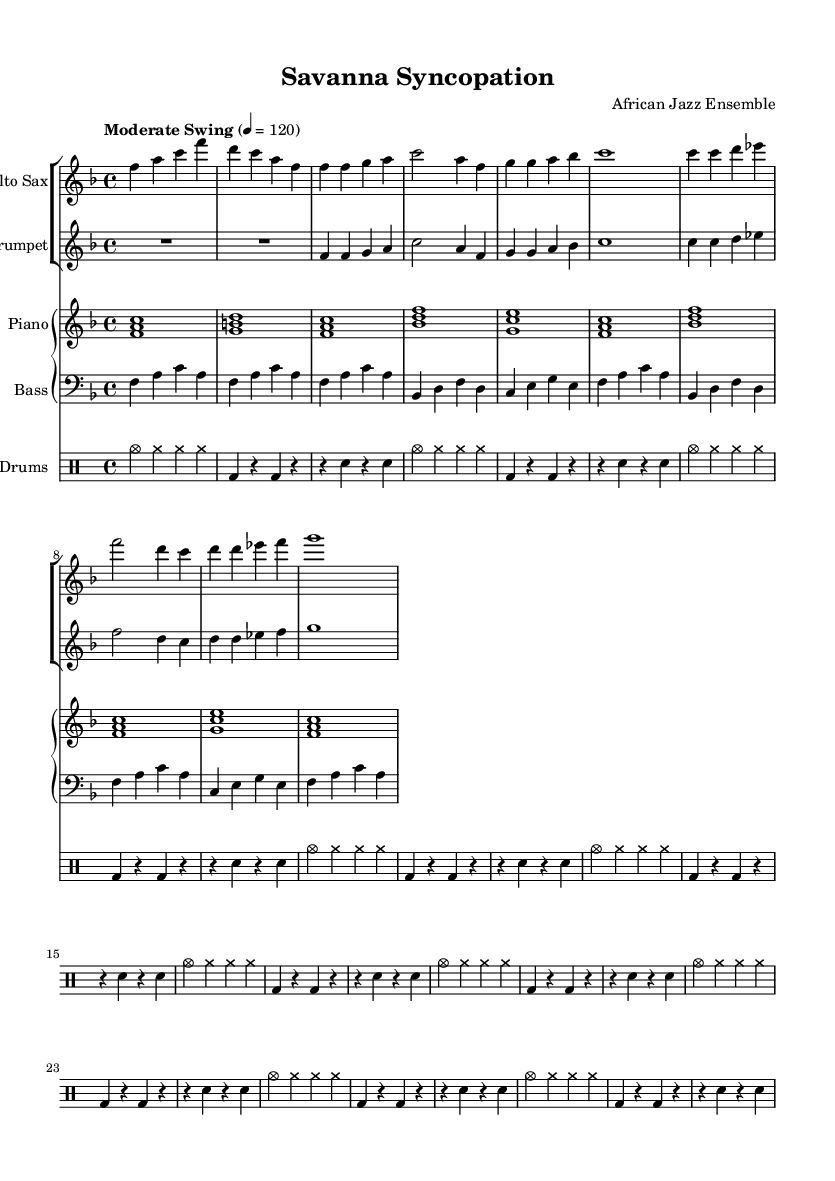What is the key signature of this music? The key signature is F major, which has one flat (B flat). You can identify it by looking at the key signature indicated at the beginning of the score.
Answer: F major What is the time signature of this music? The time signature is 4/4, which means there are four beats in each measure and the quarter note gets one beat. This can be found at the beginning of the score next to the key signature.
Answer: 4/4 What is the tempo marking for this composition? The tempo marking is "Moderate Swing," which indicates a relaxed yet swinging feel for the performance. This is stated in the tempo indication found in the score.
Answer: Moderate Swing How many instruments are featured in this arrangement? There are five instruments featured in this arrangement: Alto Saxophone, Trumpet, Piano, Bass, and Drums. This can be observed by counting the distinct staves listed in the score.
Answer: Five What is the first note played by the alto saxophone? The first note played by the alto saxophone is F. This is determined by looking at the first note in the saxophone part of the score.
Answer: F Identify the syncopation technique used in the rhythm of the piano part. The syncopation is created by emphasizing off-beats in the piano part, where the chords do not fall directly on the beat, leading to a swinging feel. This can be perceived by analyzing the placement of the notes within the measure.
Answer: Syncopation Which instrument plays the lowest range in this composition? The Bass instrument plays the lowest range, as indicated by the use of the bass clef and the lower pitch of the notes in the bass part compared to the others.
Answer: Bass 